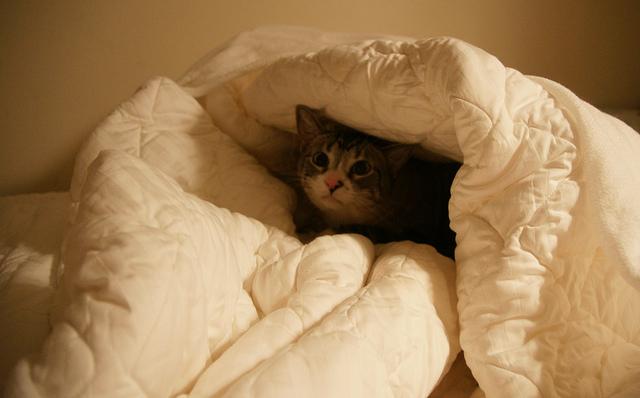What color is the blanket?
Keep it brief. White. What is covered with a blanket?
Be succinct. Cat. Would the animal under the blanket 'bark'?
Write a very short answer. No. 